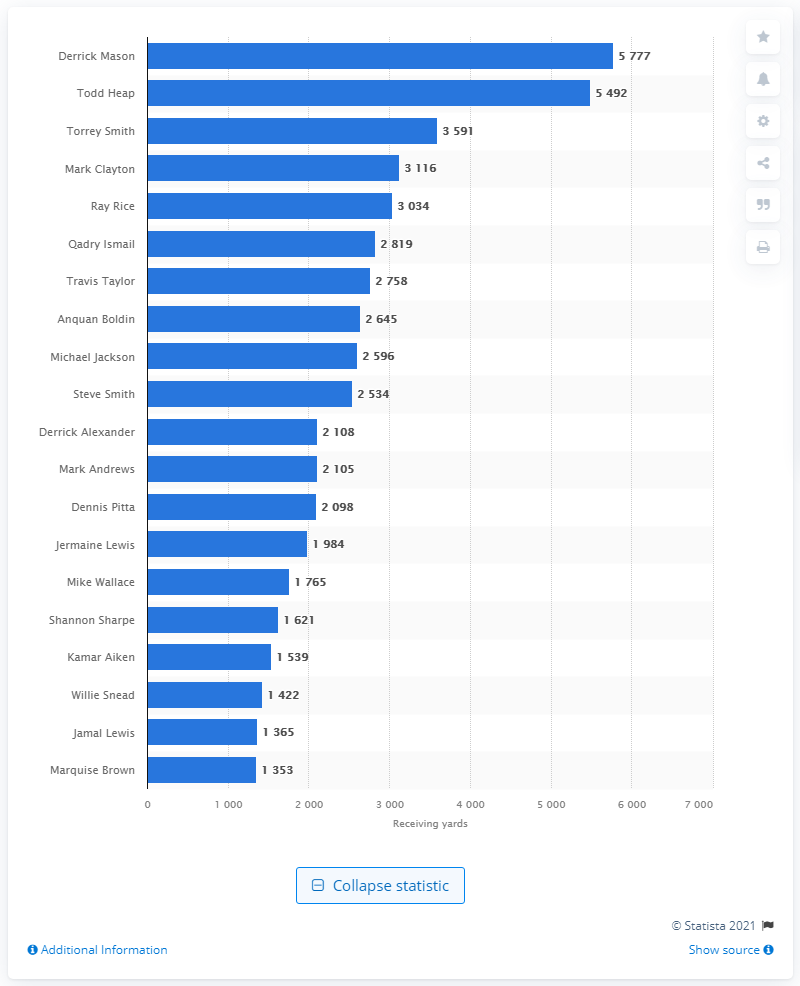Specify some key components in this picture. Derrick Mason is the career receiving leader of the Baltimore Ravens. 